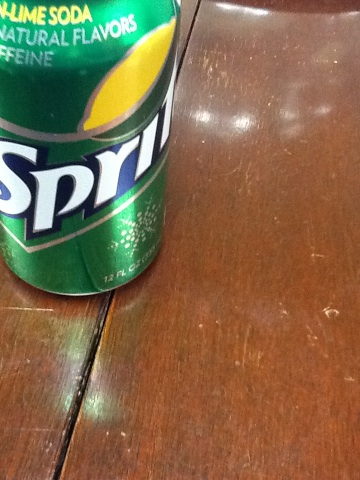Can you describe the environment where this Sprite can is placed? The Sprite can is placed on a wooden surface which suggests it might be on a table or counter, typically found in a home or dining establishment. The surface appears worn, indicating frequent use or age. 